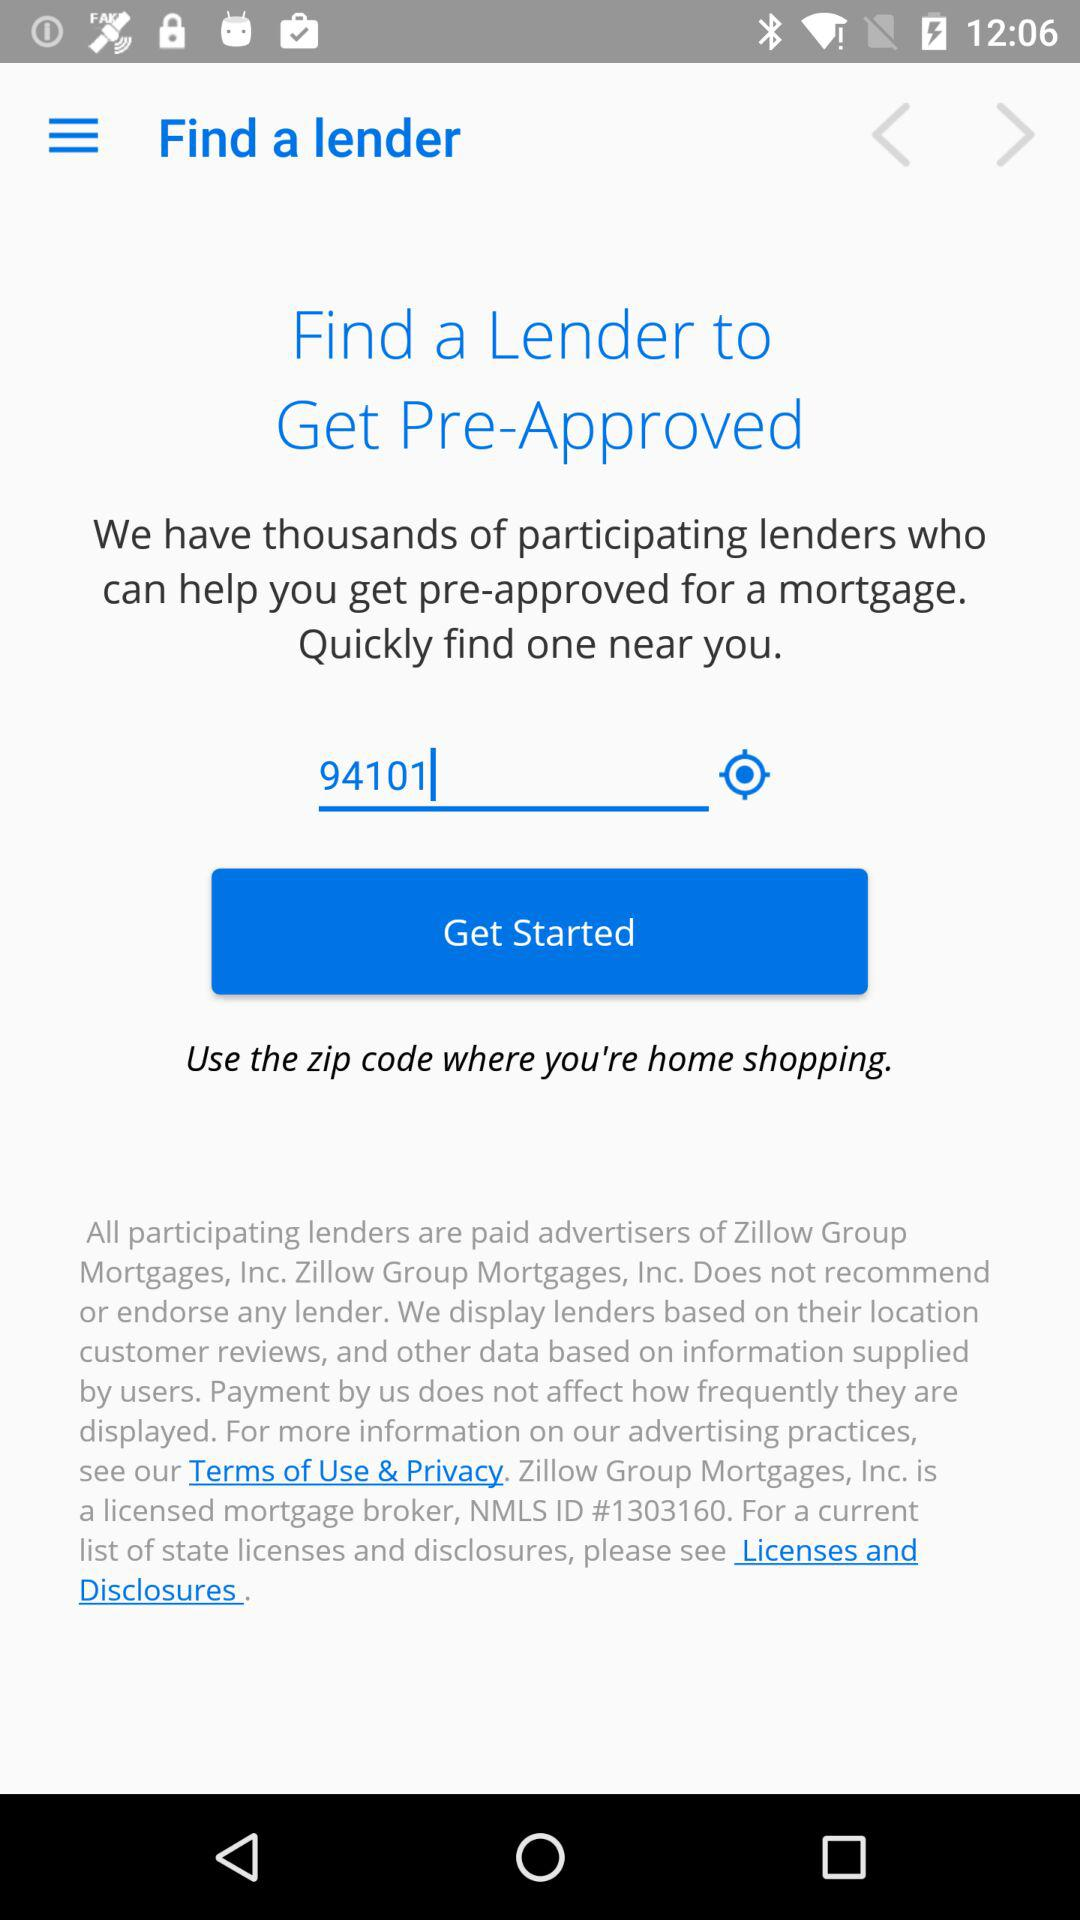How many participating lenders are there? There are thousands of participating lenders. 